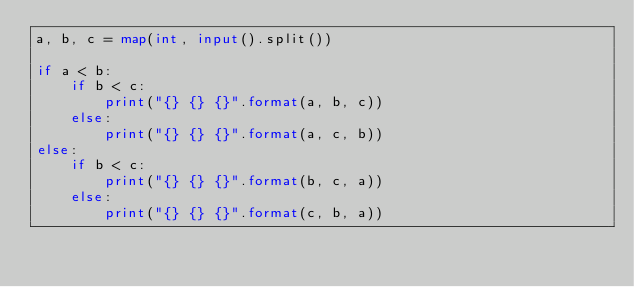Convert code to text. <code><loc_0><loc_0><loc_500><loc_500><_Python_>a, b, c = map(int, input().split())

if a < b:
    if b < c:
        print("{} {} {}".format(a, b, c))
    else:
        print("{} {} {}".format(a, c, b))
else:
    if b < c:
        print("{} {} {}".format(b, c, a))
    else:
        print("{} {} {}".format(c, b, a))
</code> 